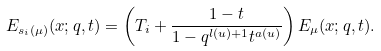<formula> <loc_0><loc_0><loc_500><loc_500>E _ { s _ { i } ( \mu ) } ( x ; q , t ) = \left ( T _ { i } + \frac { 1 - t } { 1 - q ^ { l ( u ) + 1 } t ^ { a ( u ) } } \right ) E _ { \mu } ( x ; q , t ) .</formula> 